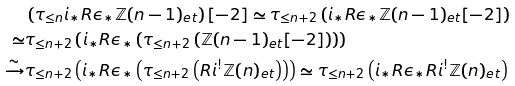<formula> <loc_0><loc_0><loc_500><loc_500>& \left ( \tau _ { \leq n } i _ { * } R \epsilon _ { * } \mathbb { Z } ( n - 1 ) _ { e t } \right ) [ - 2 ] \simeq \tau _ { \leq n + 2 } \left ( i _ { * } R \epsilon _ { * } \mathbb { Z } ( n - 1 ) _ { e t } [ - 2 ] \right ) \\ \simeq & \tau _ { \leq n + 2 } \left ( i _ { * } R \epsilon _ { * } \left ( \tau _ { \leq n + 2 } \left ( \mathbb { Z } ( n - 1 ) _ { e t } [ - 2 ] \right ) \right ) \right ) \\ \xrightarrow { \sim } & \tau _ { \leq n + 2 } \left ( i _ { * } R \epsilon _ { * } \left ( \tau _ { \leq n + 2 } \left ( R i ^ { ! } \mathbb { Z } ( n ) _ { e t } \right ) \right ) \right ) \simeq \tau _ { \leq n + 2 } \left ( i _ { * } R \epsilon _ { * } R i ^ { ! } \mathbb { Z } ( n ) _ { e t } \right )</formula> 